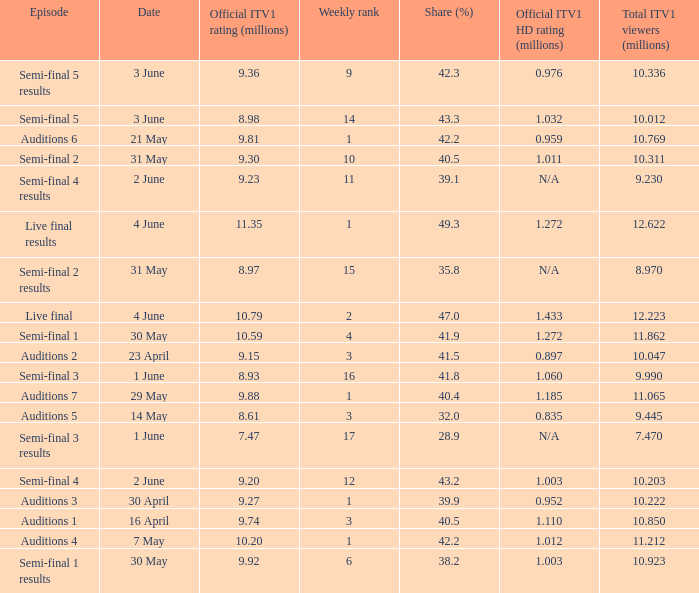Which episode had an official ITV1 HD rating of 1.185 million?  Auditions 7. 